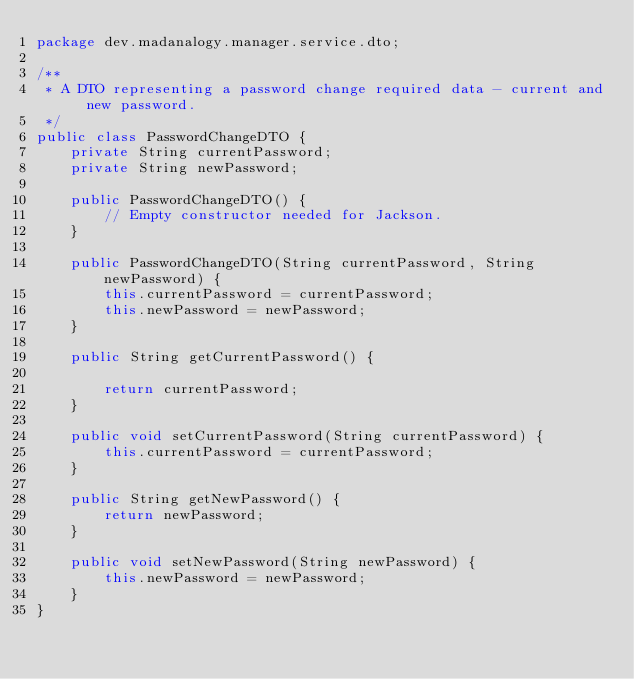Convert code to text. <code><loc_0><loc_0><loc_500><loc_500><_Java_>package dev.madanalogy.manager.service.dto;

/**
 * A DTO representing a password change required data - current and new password.
 */
public class PasswordChangeDTO {
    private String currentPassword;
    private String newPassword;

    public PasswordChangeDTO() {
        // Empty constructor needed for Jackson.
    }

    public PasswordChangeDTO(String currentPassword, String newPassword) {
        this.currentPassword = currentPassword;
        this.newPassword = newPassword;
    }

    public String getCurrentPassword() {

        return currentPassword;
    }

    public void setCurrentPassword(String currentPassword) {
        this.currentPassword = currentPassword;
    }

    public String getNewPassword() {
        return newPassword;
    }

    public void setNewPassword(String newPassword) {
        this.newPassword = newPassword;
    }
}
</code> 